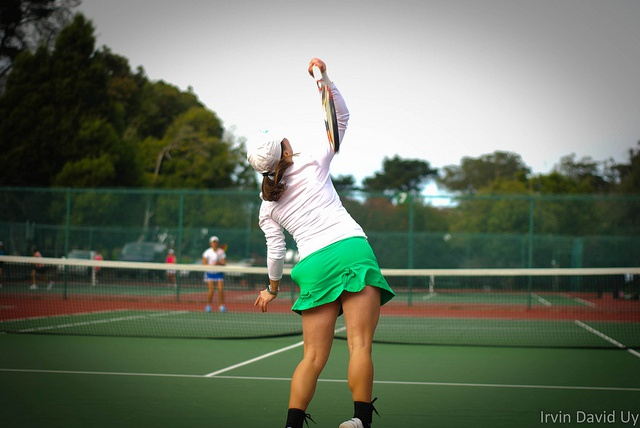Describe the objects in this image and their specific colors. I can see people in black, white, brown, and tan tones, people in black, brown, maroon, lightgray, and darkgray tones, tennis racket in black, white, tan, and gray tones, car in black, teal, and darkgreen tones, and car in black, gray, teal, and darkgreen tones in this image. 